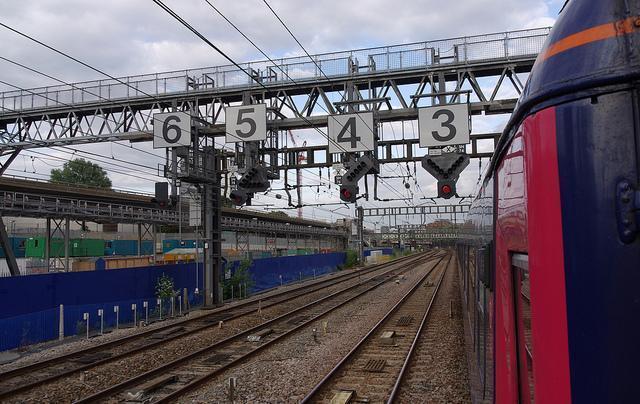What is the next number in the sequence?
Make your selection from the four choices given to correctly answer the question.
Options: One, ten, two, eight. Two. 